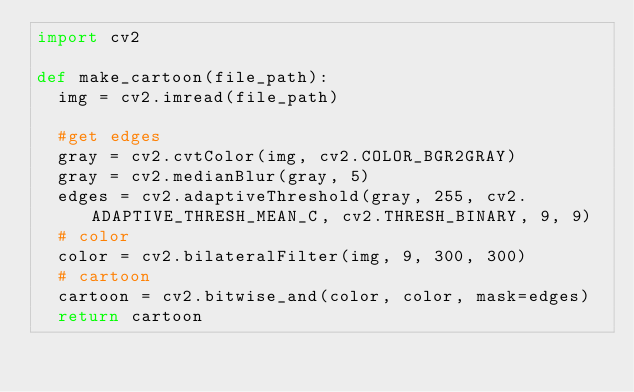<code> <loc_0><loc_0><loc_500><loc_500><_Python_>import cv2

def make_cartoon(file_path):
	img = cv2.imread(file_path)
	
	#get edges
	gray = cv2.cvtColor(img, cv2.COLOR_BGR2GRAY)
	gray = cv2.medianBlur(gray, 5)
	edges = cv2.adaptiveThreshold(gray, 255, cv2.ADAPTIVE_THRESH_MEAN_C, cv2.THRESH_BINARY, 9, 9)
	# color
	color = cv2.bilateralFilter(img, 9, 300, 300)
	# cartoon
	cartoon = cv2.bitwise_and(color, color, mask=edges)
	return cartoon
	
</code> 